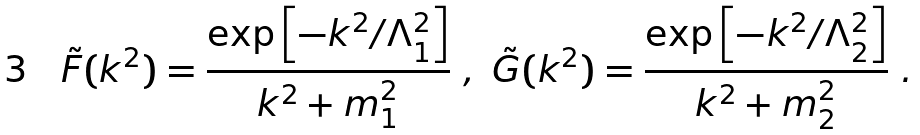<formula> <loc_0><loc_0><loc_500><loc_500>\tilde { F } ( { k } ^ { 2 } ) = \frac { \exp \left [ - { k } ^ { 2 } / \Lambda _ { 1 } ^ { 2 } \right ] } { { k } ^ { 2 } + m _ { 1 } ^ { 2 } } \ , \ \tilde { G } ( { k } ^ { 2 } ) = \frac { \exp \left [ - { k } ^ { 2 } / \Lambda _ { 2 } ^ { 2 } \right ] } { { k } ^ { 2 } + m _ { 2 } ^ { 2 } } \ .</formula> 